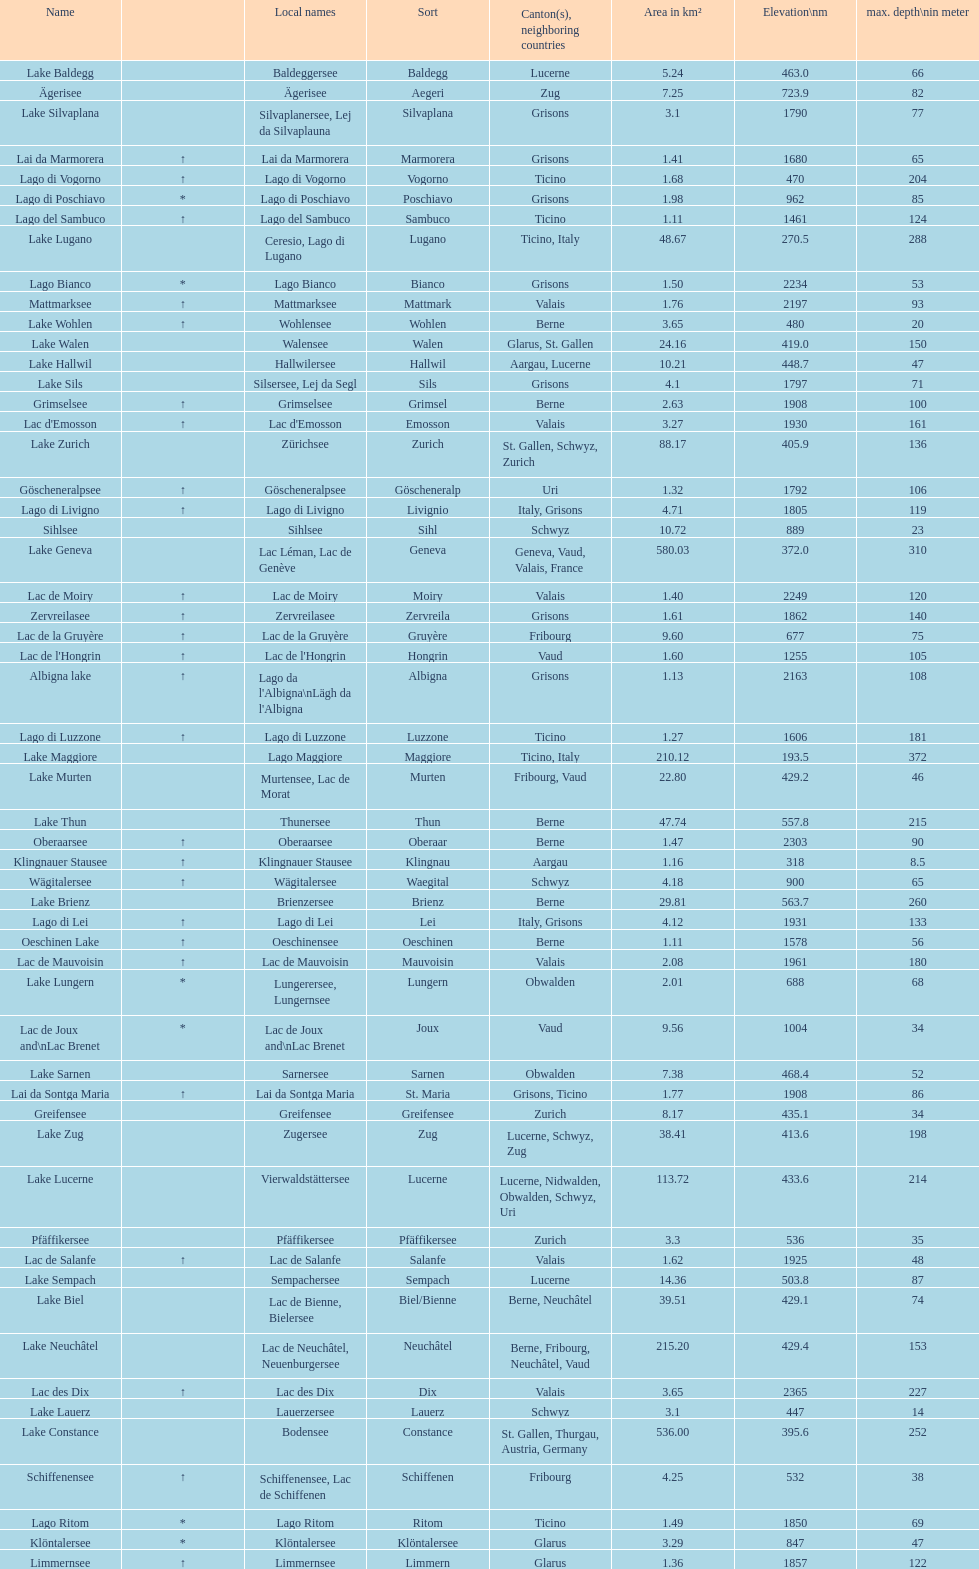Which is the only lake with a max depth of 372m? Lake Maggiore. 